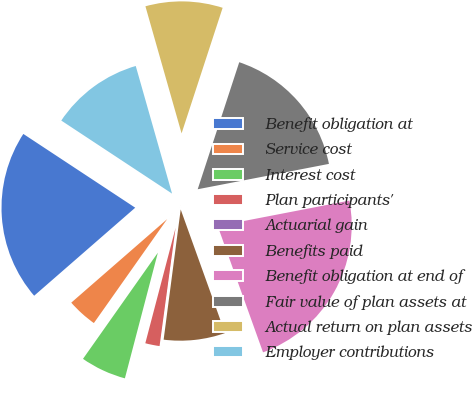Convert chart to OTSL. <chart><loc_0><loc_0><loc_500><loc_500><pie_chart><fcel>Benefit obligation at<fcel>Service cost<fcel>Interest cost<fcel>Plan participants'<fcel>Actuarial gain<fcel>Benefits paid<fcel>Benefit obligation at end of<fcel>Fair value of plan assets at<fcel>Actual return on plan assets<fcel>Employer contributions<nl><fcel>20.68%<fcel>3.82%<fcel>5.69%<fcel>1.94%<fcel>0.07%<fcel>7.56%<fcel>22.55%<fcel>16.93%<fcel>9.44%<fcel>11.31%<nl></chart> 